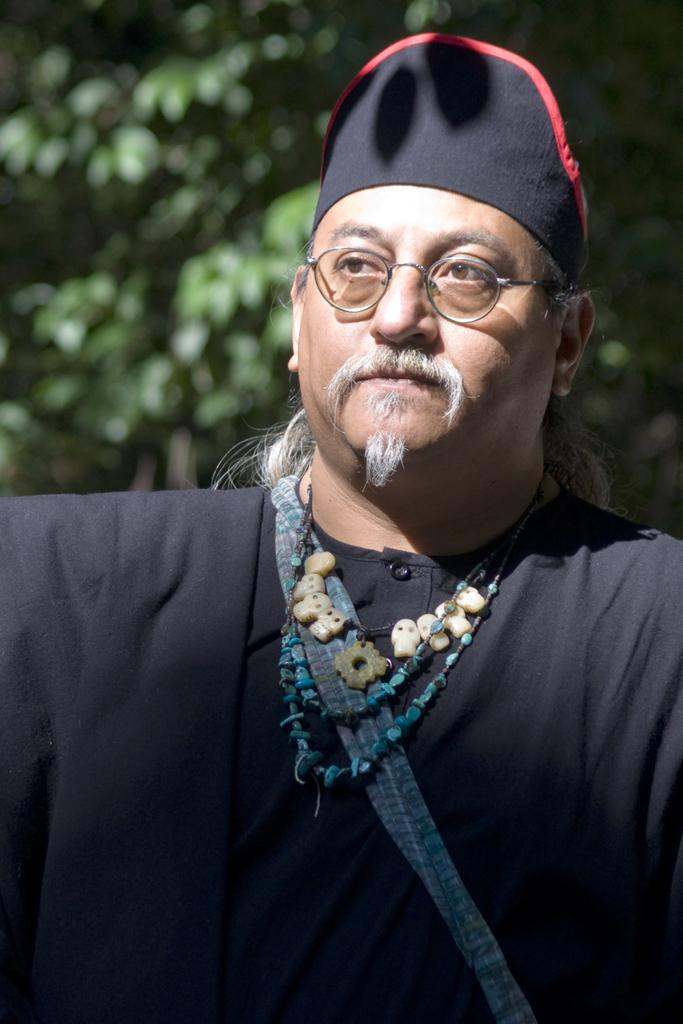Who is the main subject in the foreground of the image? There is a man in the foreground of the image. What is the man wearing on his head? The man is wearing a cap. What else is the man wearing in the image? The man is wearing some ornaments. What can be seen in the background of the image? The background of the image is blurry, and trees are visible. How many sisters are standing next to the man in the image? There are no sisters present in the image; it only features a man in the foreground. What type of tin is being used to create harmony in the image? There is no tin or any indication of harmony in the image; it is focused on the man and his attire. 